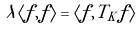<formula> <loc_0><loc_0><loc_500><loc_500>\lambda \langle f , f \rangle = \langle f , T _ { K } f \rangle</formula> 